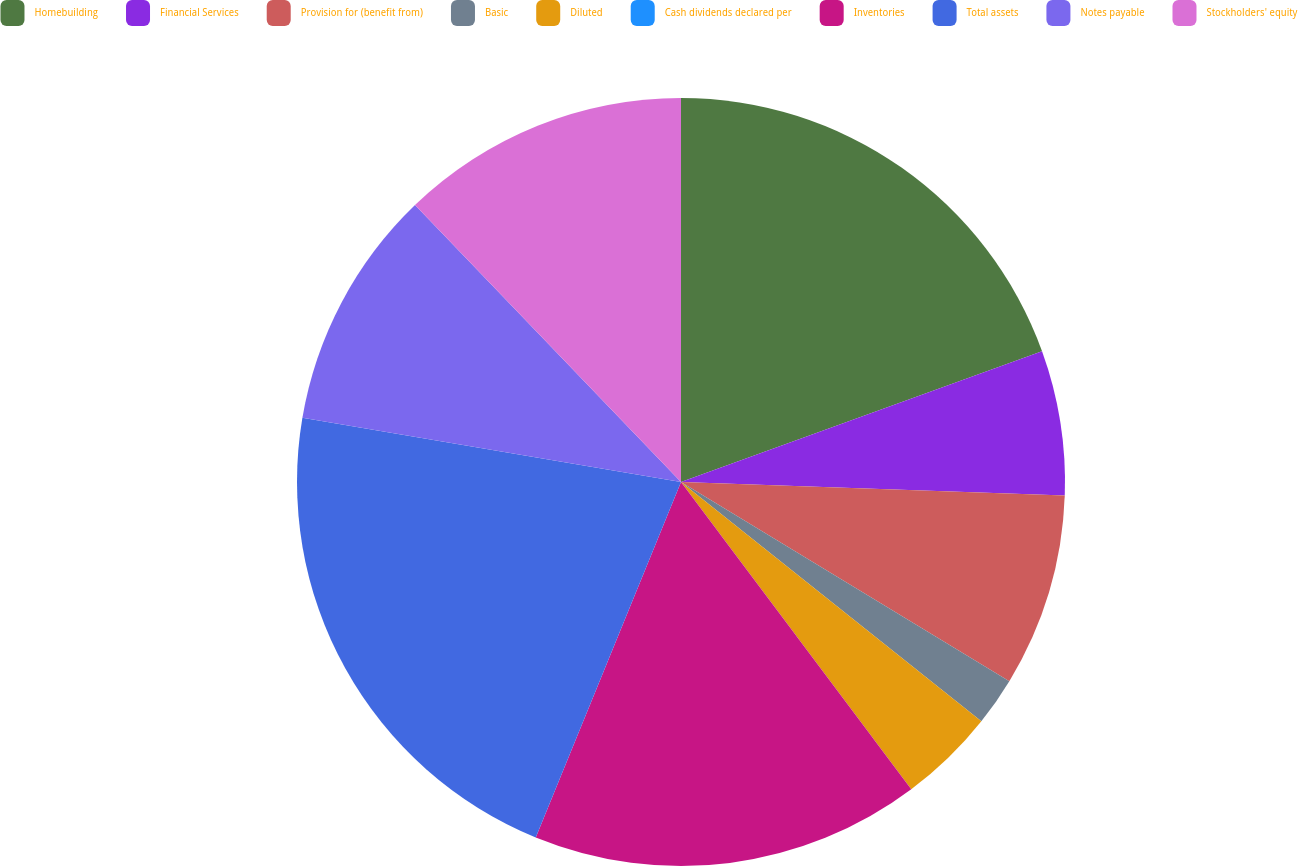<chart> <loc_0><loc_0><loc_500><loc_500><pie_chart><fcel>Homebuilding<fcel>Financial Services<fcel>Provision for (benefit from)<fcel>Basic<fcel>Diluted<fcel>Cash dividends declared per<fcel>Inventories<fcel>Total assets<fcel>Notes payable<fcel>Stockholders' equity<nl><fcel>19.47%<fcel>6.09%<fcel>8.12%<fcel>2.03%<fcel>4.06%<fcel>0.0%<fcel>16.41%<fcel>21.5%<fcel>10.15%<fcel>12.18%<nl></chart> 